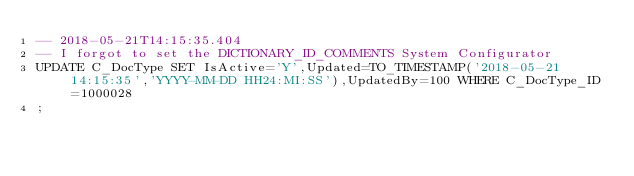Convert code to text. <code><loc_0><loc_0><loc_500><loc_500><_SQL_>-- 2018-05-21T14:15:35.404
-- I forgot to set the DICTIONARY_ID_COMMENTS System Configurator
UPDATE C_DocType SET IsActive='Y',Updated=TO_TIMESTAMP('2018-05-21 14:15:35','YYYY-MM-DD HH24:MI:SS'),UpdatedBy=100 WHERE C_DocType_ID=1000028
;
</code> 